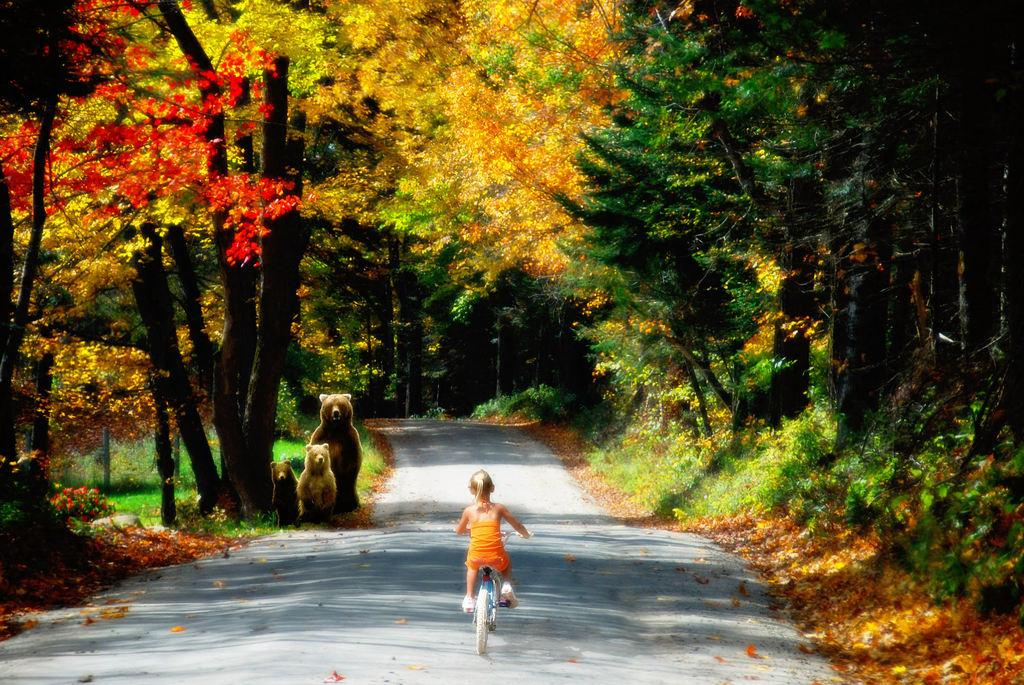What is the girl doing in the image? The girl is riding a bicycle in the image. Where is the girl riding her bicycle? The girl is on the road in the image. What can be seen in the background of the image? Grass and trees are visible in the image. How many bears are on the road in the image? There are three bears on the road in the image. What time of day does the image appear to be taken? The image appears to be taken during the day. What type of story is being told in the hall in the image? There is no hall or story present in the image; it features a girl riding a bicycle on the road with three bears nearby. 